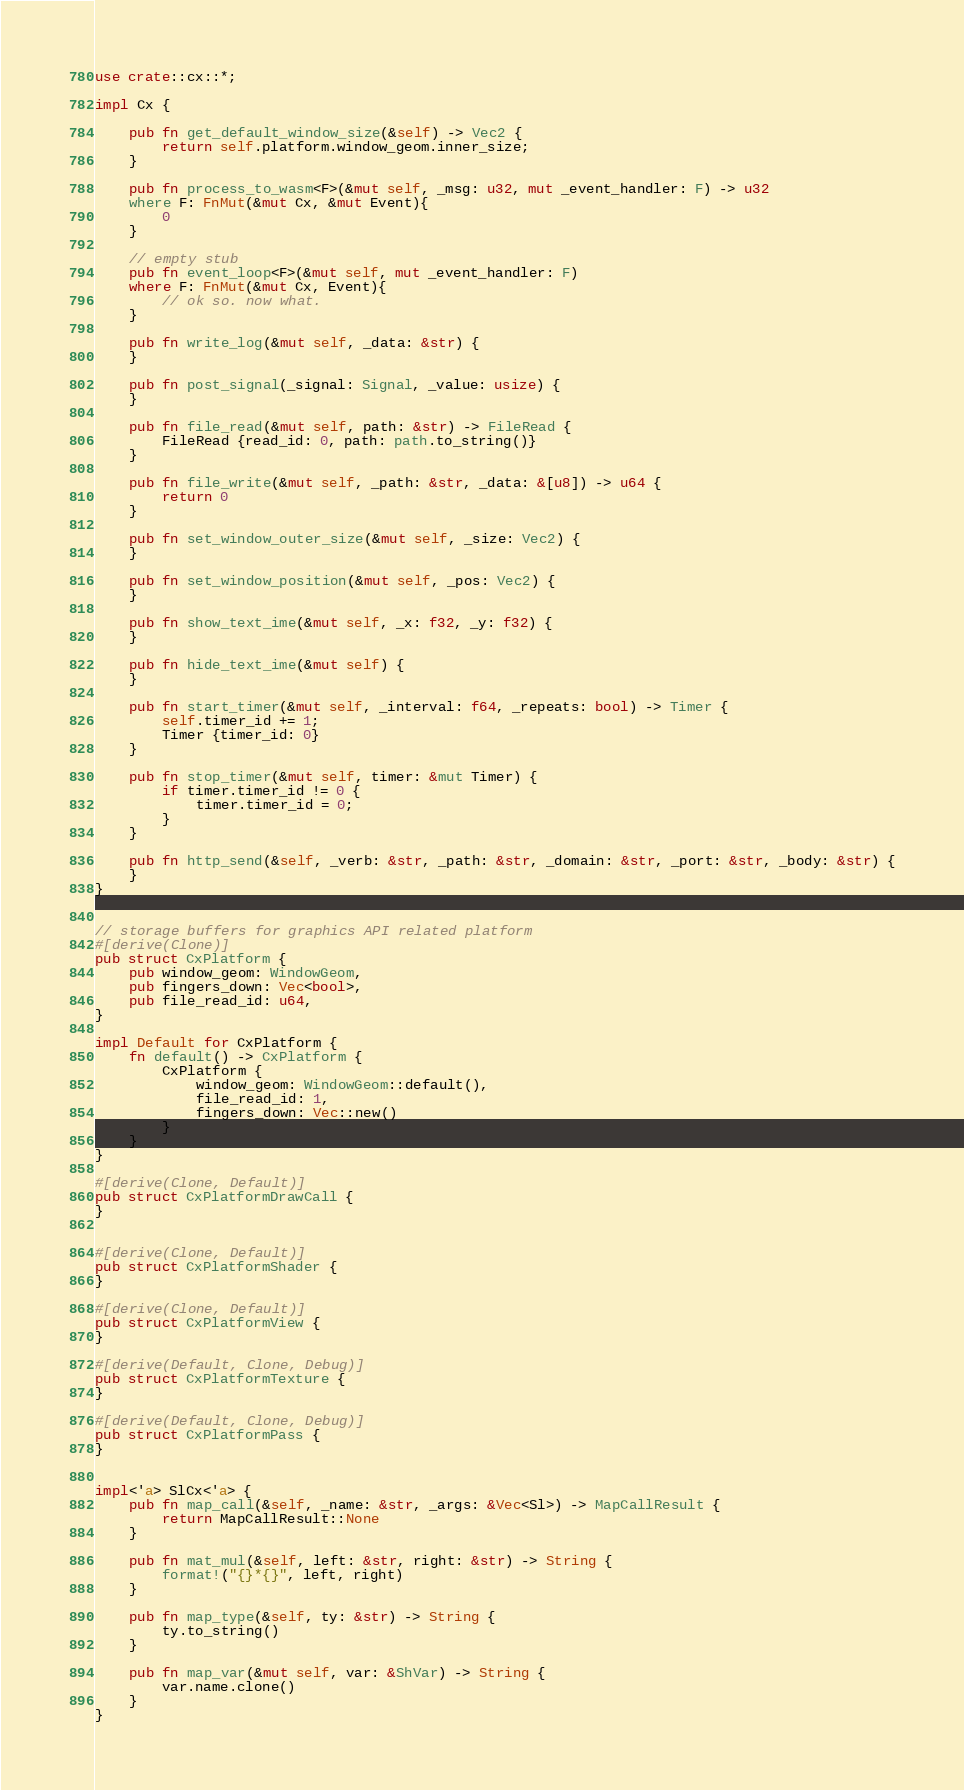<code> <loc_0><loc_0><loc_500><loc_500><_Rust_>
use crate::cx::*;

impl Cx {
    
    pub fn get_default_window_size(&self) -> Vec2 {
        return self.platform.window_geom.inner_size;
    }

    pub fn process_to_wasm<F>(&mut self, _msg: u32, mut _event_handler: F) -> u32
    where F: FnMut(&mut Cx, &mut Event){
        0
    }
    
    // empty stub
    pub fn event_loop<F>(&mut self, mut _event_handler: F)
    where F: FnMut(&mut Cx, Event){
        // ok so. now what.
    }
    
    pub fn write_log(&mut self, _data: &str) {
    }
    
    pub fn post_signal(_signal: Signal, _value: usize) {
    }
    
    pub fn file_read(&mut self, path: &str) -> FileRead {
        FileRead {read_id: 0, path: path.to_string()}
    }
    
    pub fn file_write(&mut self, _path: &str, _data: &[u8]) -> u64 {
        return 0
    }
    
    pub fn set_window_outer_size(&mut self, _size: Vec2) {
    }
    
    pub fn set_window_position(&mut self, _pos: Vec2) {
    }
    
    pub fn show_text_ime(&mut self, _x: f32, _y: f32) {
    }
    
    pub fn hide_text_ime(&mut self) {
    }
    
    pub fn start_timer(&mut self, _interval: f64, _repeats: bool) -> Timer {
        self.timer_id += 1;
        Timer {timer_id: 0}
    }
    
    pub fn stop_timer(&mut self, timer: &mut Timer) {
        if timer.timer_id != 0 {
            timer.timer_id = 0;
        }
    }
    
    pub fn http_send(&self, _verb: &str, _path: &str, _domain: &str, _port: &str, _body: &str) {
    }
}


// storage buffers for graphics API related platform
#[derive(Clone)]
pub struct CxPlatform {
    pub window_geom: WindowGeom,
    pub fingers_down: Vec<bool>,
    pub file_read_id: u64,
}

impl Default for CxPlatform {
    fn default() -> CxPlatform {
        CxPlatform {
            window_geom: WindowGeom::default(),
            file_read_id: 1,
            fingers_down: Vec::new()
        }
    }
}

#[derive(Clone, Default)]
pub struct CxPlatformDrawCall {
}


#[derive(Clone, Default)]
pub struct CxPlatformShader {
}

#[derive(Clone, Default)]
pub struct CxPlatformView {
}

#[derive(Default, Clone, Debug)]
pub struct CxPlatformTexture {
}

#[derive(Default, Clone, Debug)]
pub struct CxPlatformPass {
}


impl<'a> SlCx<'a> {
    pub fn map_call(&self, _name: &str, _args: &Vec<Sl>) -> MapCallResult {
        return MapCallResult::None
    }
    
    pub fn mat_mul(&self, left: &str, right: &str) -> String {
        format!("{}*{}", left, right)
    }
    
    pub fn map_type(&self, ty: &str) -> String {
        ty.to_string()
    }
    
    pub fn map_var(&mut self, var: &ShVar) -> String {
        var.name.clone()
    }
}</code> 